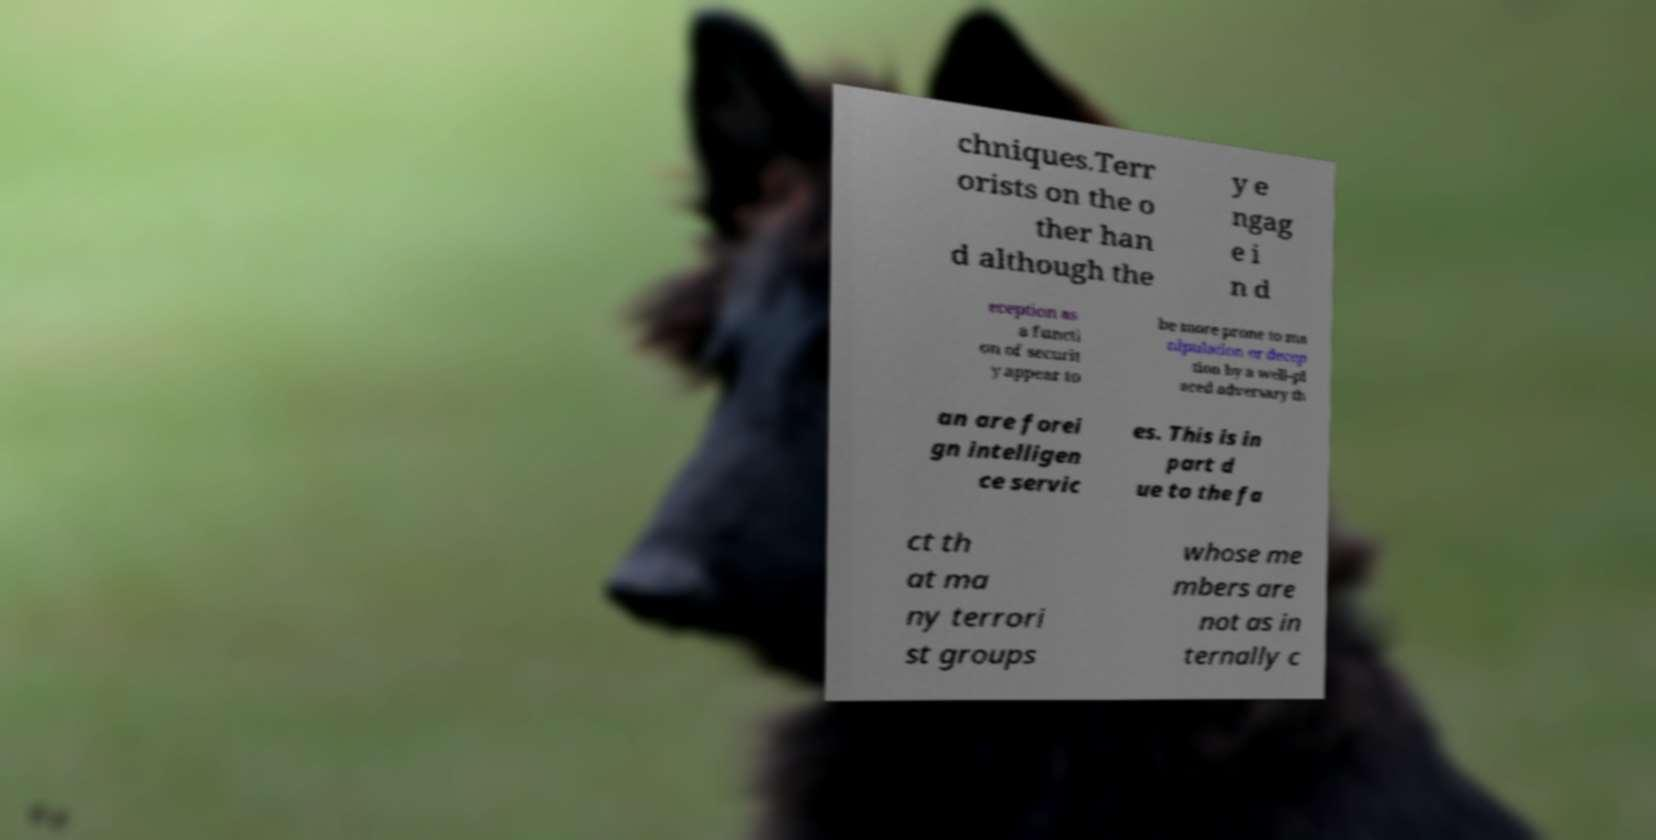Could you assist in decoding the text presented in this image and type it out clearly? chniques.Terr orists on the o ther han d although the y e ngag e i n d eception as a functi on of securit y appear to be more prone to ma nipulation or decep tion by a well-pl aced adversary th an are forei gn intelligen ce servic es. This is in part d ue to the fa ct th at ma ny terrori st groups whose me mbers are not as in ternally c 